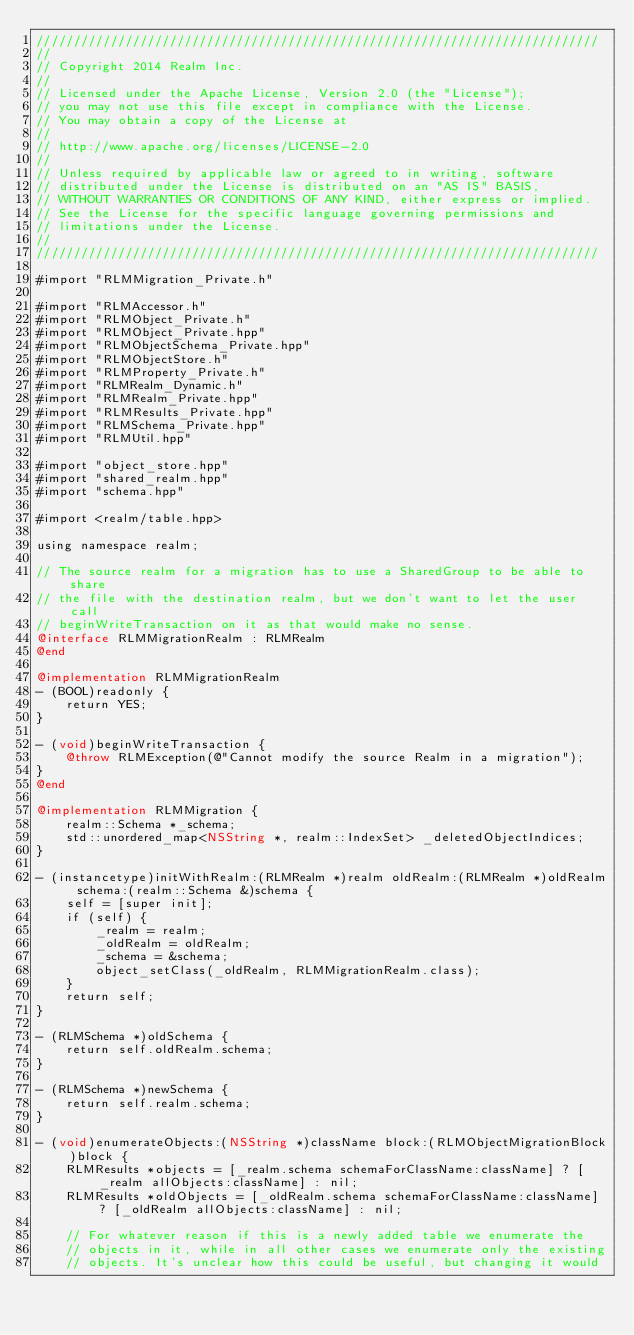Convert code to text. <code><loc_0><loc_0><loc_500><loc_500><_ObjectiveC_>////////////////////////////////////////////////////////////////////////////
//
// Copyright 2014 Realm Inc.
//
// Licensed under the Apache License, Version 2.0 (the "License");
// you may not use this file except in compliance with the License.
// You may obtain a copy of the License at
//
// http://www.apache.org/licenses/LICENSE-2.0
//
// Unless required by applicable law or agreed to in writing, software
// distributed under the License is distributed on an "AS IS" BASIS,
// WITHOUT WARRANTIES OR CONDITIONS OF ANY KIND, either express or implied.
// See the License for the specific language governing permissions and
// limitations under the License.
//
////////////////////////////////////////////////////////////////////////////

#import "RLMMigration_Private.h"

#import "RLMAccessor.h"
#import "RLMObject_Private.h"
#import "RLMObject_Private.hpp"
#import "RLMObjectSchema_Private.hpp"
#import "RLMObjectStore.h"
#import "RLMProperty_Private.h"
#import "RLMRealm_Dynamic.h"
#import "RLMRealm_Private.hpp"
#import "RLMResults_Private.hpp"
#import "RLMSchema_Private.hpp"
#import "RLMUtil.hpp"

#import "object_store.hpp"
#import "shared_realm.hpp"
#import "schema.hpp"

#import <realm/table.hpp>

using namespace realm;

// The source realm for a migration has to use a SharedGroup to be able to share
// the file with the destination realm, but we don't want to let the user call
// beginWriteTransaction on it as that would make no sense.
@interface RLMMigrationRealm : RLMRealm
@end

@implementation RLMMigrationRealm
- (BOOL)readonly {
    return YES;
}

- (void)beginWriteTransaction {
    @throw RLMException(@"Cannot modify the source Realm in a migration");
}
@end

@implementation RLMMigration {
    realm::Schema *_schema;
    std::unordered_map<NSString *, realm::IndexSet> _deletedObjectIndices;
}

- (instancetype)initWithRealm:(RLMRealm *)realm oldRealm:(RLMRealm *)oldRealm schema:(realm::Schema &)schema {
    self = [super init];
    if (self) {
        _realm = realm;
        _oldRealm = oldRealm;
        _schema = &schema;
        object_setClass(_oldRealm, RLMMigrationRealm.class);
    }
    return self;
}

- (RLMSchema *)oldSchema {
    return self.oldRealm.schema;
}

- (RLMSchema *)newSchema {
    return self.realm.schema;
}

- (void)enumerateObjects:(NSString *)className block:(RLMObjectMigrationBlock)block {
    RLMResults *objects = [_realm.schema schemaForClassName:className] ? [_realm allObjects:className] : nil;
    RLMResults *oldObjects = [_oldRealm.schema schemaForClassName:className] ? [_oldRealm allObjects:className] : nil;

    // For whatever reason if this is a newly added table we enumerate the
    // objects in it, while in all other cases we enumerate only the existing
    // objects. It's unclear how this could be useful, but changing it would</code> 